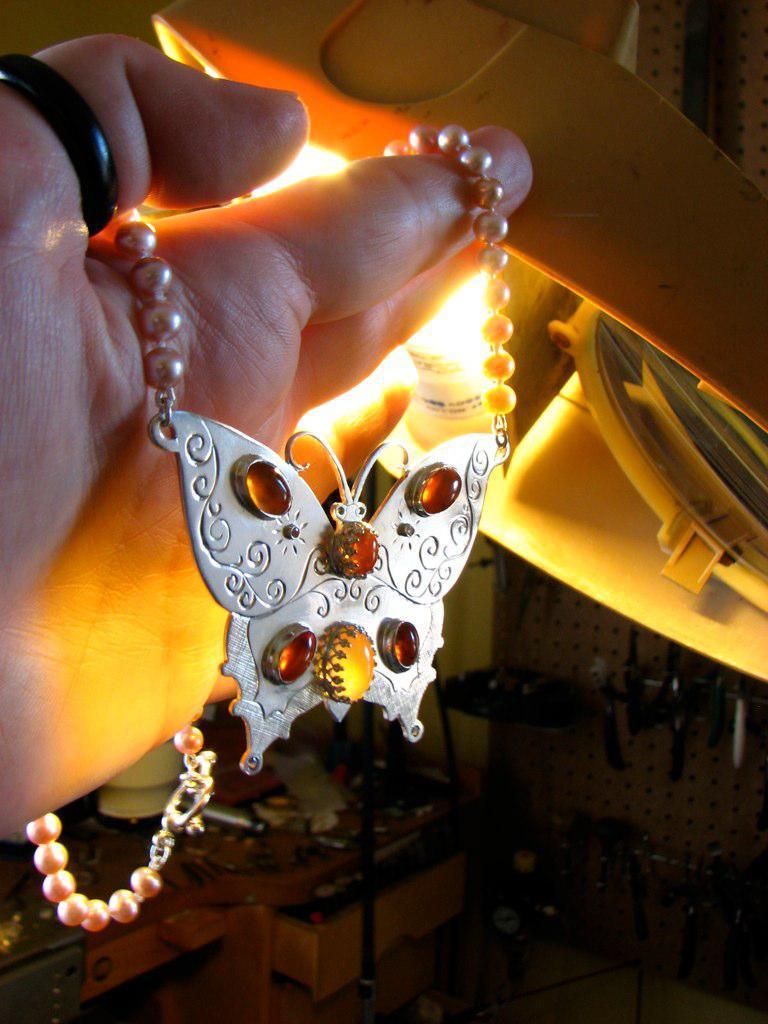Please provide a concise description of this image. Here we can see a person hand and on the fingers we can see a chain with a butterfly locket and to the thumb finger there is a black ring. In the background we can see a light,some objects on the table and we can see a rack and tools over here at the bottom. 